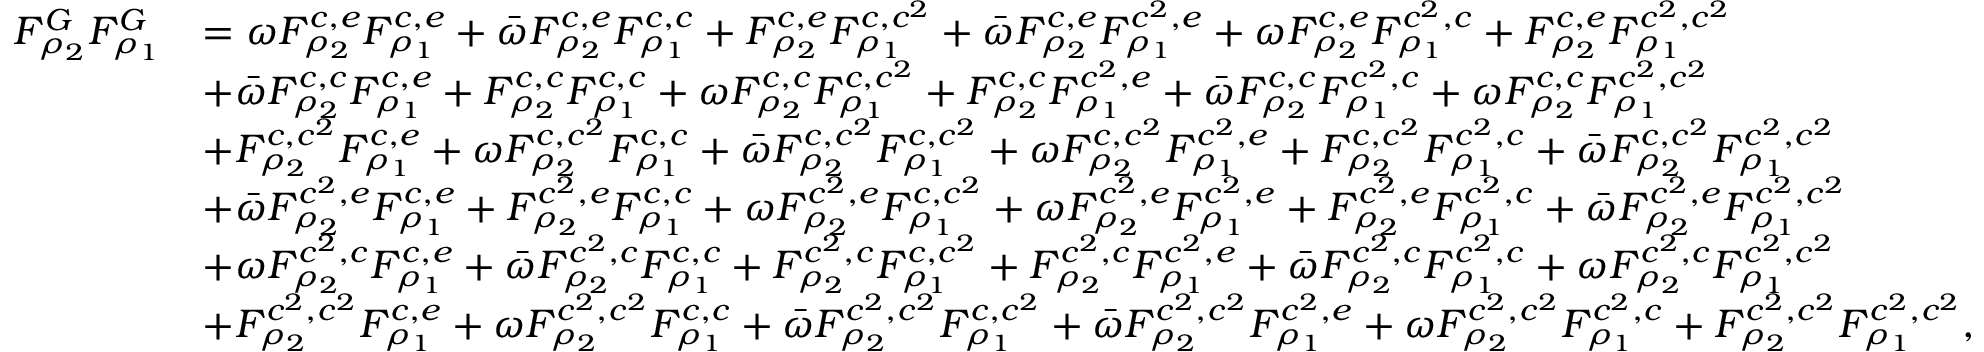Convert formula to latex. <formula><loc_0><loc_0><loc_500><loc_500>\begin{array} { r l } { F _ { \rho _ { 2 } } ^ { G } F _ { \rho _ { 1 } } ^ { G } } & { = \omega F _ { \rho _ { 2 } } ^ { c , e } F _ { \rho _ { 1 } } ^ { c , e } + \bar { \omega } F _ { \rho _ { 2 } } ^ { c , e } F _ { \rho _ { 1 } } ^ { c , c } + F _ { \rho _ { 2 } } ^ { c , e } F _ { \rho _ { 1 } } ^ { c , c ^ { 2 } } + \bar { \omega } F _ { \rho _ { 2 } } ^ { c , e } F _ { \rho _ { 1 } } ^ { c ^ { 2 } , e } + \omega F _ { \rho _ { 2 } } ^ { c , e } F _ { \rho _ { 1 } } ^ { c ^ { 2 } , c } + F _ { \rho _ { 2 } } ^ { c , e } F _ { \rho _ { 1 } } ^ { c ^ { 2 } , c ^ { 2 } } } \\ & { + \bar { \omega } F _ { \rho _ { 2 } } ^ { c , c } F _ { \rho _ { 1 } } ^ { c , e } + F _ { \rho _ { 2 } } ^ { c , c } F _ { \rho _ { 1 } } ^ { c , c } + \omega F _ { \rho _ { 2 } } ^ { c , c } F _ { \rho _ { 1 } } ^ { c , c ^ { 2 } } + F _ { \rho _ { 2 } } ^ { c , c } F _ { \rho _ { 1 } } ^ { c ^ { 2 } , e } + \bar { \omega } F _ { \rho _ { 2 } } ^ { c , c } F _ { \rho _ { 1 } } ^ { c ^ { 2 } , c } + \omega F _ { \rho _ { 2 } } ^ { c , c } F _ { \rho _ { 1 } } ^ { c ^ { 2 } , c ^ { 2 } } } \\ & { + F _ { \rho _ { 2 } } ^ { c , c ^ { 2 } } F _ { \rho _ { 1 } } ^ { c , e } + \omega F _ { \rho _ { 2 } } ^ { c , c ^ { 2 } } F _ { \rho _ { 1 } } ^ { c , c } + \bar { \omega } F _ { \rho _ { 2 } } ^ { c , c ^ { 2 } } F _ { \rho _ { 1 } } ^ { c , c ^ { 2 } } + \omega F _ { \rho _ { 2 } } ^ { c , c ^ { 2 } } F _ { \rho _ { 1 } } ^ { c ^ { 2 } , e } + F _ { \rho _ { 2 } } ^ { c , c ^ { 2 } } F _ { \rho _ { 1 } } ^ { c ^ { 2 } , c } + \bar { \omega } F _ { \rho _ { 2 } } ^ { c , c ^ { 2 } } F _ { \rho _ { 1 } } ^ { c ^ { 2 } , c ^ { 2 } } } \\ & { + \bar { \omega } F _ { \rho _ { 2 } } ^ { c ^ { 2 } , e } F _ { \rho _ { 1 } } ^ { c , e } + F _ { \rho _ { 2 } } ^ { c ^ { 2 } , e } F _ { \rho _ { 1 } } ^ { c , c } + \omega F _ { \rho _ { 2 } } ^ { c ^ { 2 } , e } F _ { \rho _ { 1 } } ^ { c , c ^ { 2 } } + \omega F _ { \rho _ { 2 } } ^ { c ^ { 2 } , e } F _ { \rho _ { 1 } } ^ { c ^ { 2 } , e } + F _ { \rho _ { 2 } } ^ { c ^ { 2 } , e } F _ { \rho _ { 1 } } ^ { c ^ { 2 } , c } + \bar { \omega } F _ { \rho _ { 2 } } ^ { c ^ { 2 } , e } F _ { \rho _ { 1 } } ^ { c ^ { 2 } , c ^ { 2 } } } \\ & { + \omega F _ { \rho _ { 2 } } ^ { c ^ { 2 } , c } F _ { \rho _ { 1 } } ^ { c , e } + \bar { \omega } F _ { \rho _ { 2 } } ^ { c ^ { 2 } , c } F _ { \rho _ { 1 } } ^ { c , c } + F _ { \rho _ { 2 } } ^ { c ^ { 2 } , c } F _ { \rho _ { 1 } } ^ { c , c ^ { 2 } } + F _ { \rho _ { 2 } } ^ { c ^ { 2 } , c } F _ { \rho _ { 1 } } ^ { c ^ { 2 } , e } + \bar { \omega } F _ { \rho _ { 2 } } ^ { c ^ { 2 } , c } F _ { \rho _ { 1 } } ^ { c ^ { 2 } , c } + \omega F _ { \rho _ { 2 } } ^ { c ^ { 2 } , c } F _ { \rho _ { 1 } } ^ { c ^ { 2 } , c ^ { 2 } } } \\ & { + F _ { \rho _ { 2 } } ^ { c ^ { 2 } , c ^ { 2 } } F _ { \rho _ { 1 } } ^ { c , e } + \omega F _ { \rho _ { 2 } } ^ { c ^ { 2 } , c ^ { 2 } } F _ { \rho _ { 1 } } ^ { c , c } + \bar { \omega } F _ { \rho _ { 2 } } ^ { c ^ { 2 } , c ^ { 2 } } F _ { \rho _ { 1 } } ^ { c , c ^ { 2 } } + \bar { \omega } F _ { \rho _ { 2 } } ^ { c ^ { 2 } , c ^ { 2 } } F _ { \rho _ { 1 } } ^ { c ^ { 2 } , e } + \omega F _ { \rho _ { 2 } } ^ { c ^ { 2 } , c ^ { 2 } } F _ { \rho _ { 1 } } ^ { c ^ { 2 } , c } + F _ { \rho _ { 2 } } ^ { c ^ { 2 } , c ^ { 2 } } F _ { \rho _ { 1 } } ^ { c ^ { 2 } , c ^ { 2 } } , } \end{array}</formula> 